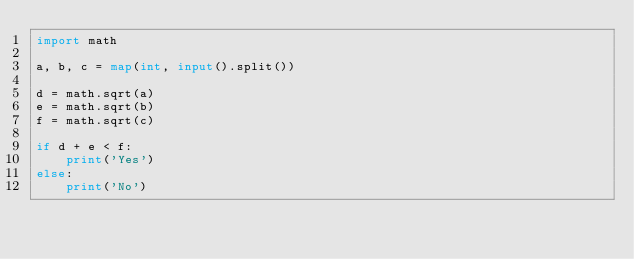Convert code to text. <code><loc_0><loc_0><loc_500><loc_500><_Python_>import math

a, b, c = map(int, input().split())

d = math.sqrt(a)
e = math.sqrt(b)
f = math.sqrt(c)

if d + e < f:
    print('Yes')
else:
    print('No')</code> 